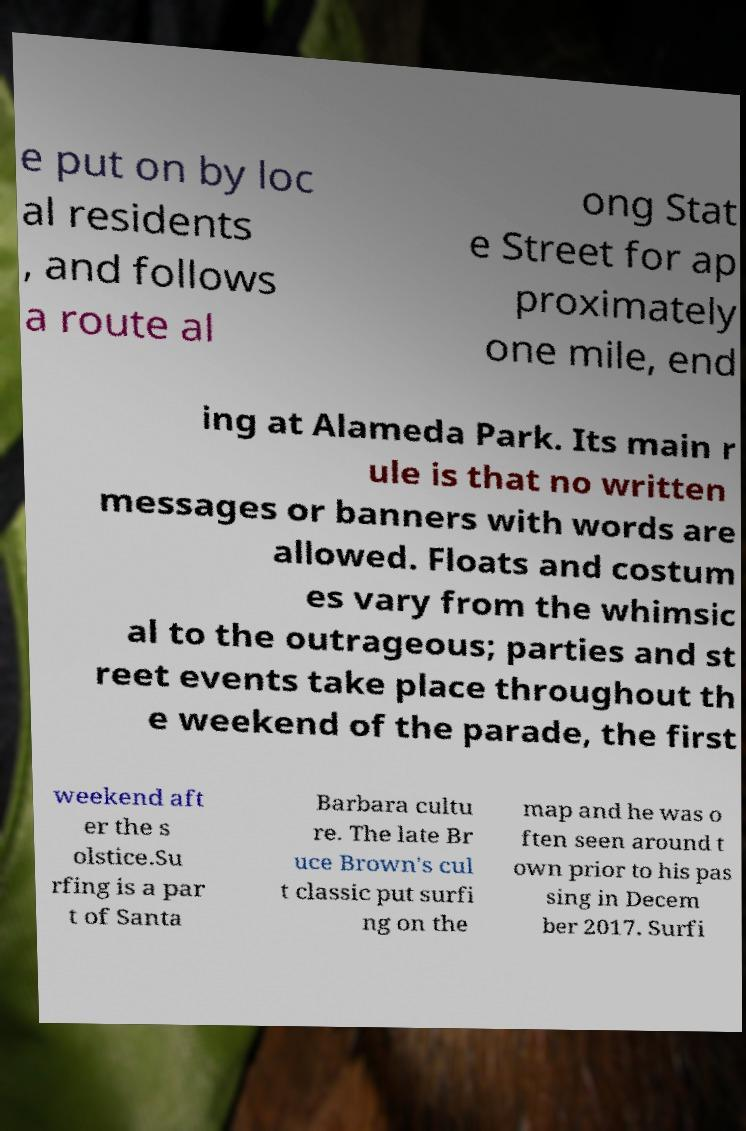There's text embedded in this image that I need extracted. Can you transcribe it verbatim? e put on by loc al residents , and follows a route al ong Stat e Street for ap proximately one mile, end ing at Alameda Park. Its main r ule is that no written messages or banners with words are allowed. Floats and costum es vary from the whimsic al to the outrageous; parties and st reet events take place throughout th e weekend of the parade, the first weekend aft er the s olstice.Su rfing is a par t of Santa Barbara cultu re. The late Br uce Brown's cul t classic put surfi ng on the map and he was o ften seen around t own prior to his pas sing in Decem ber 2017. Surfi 